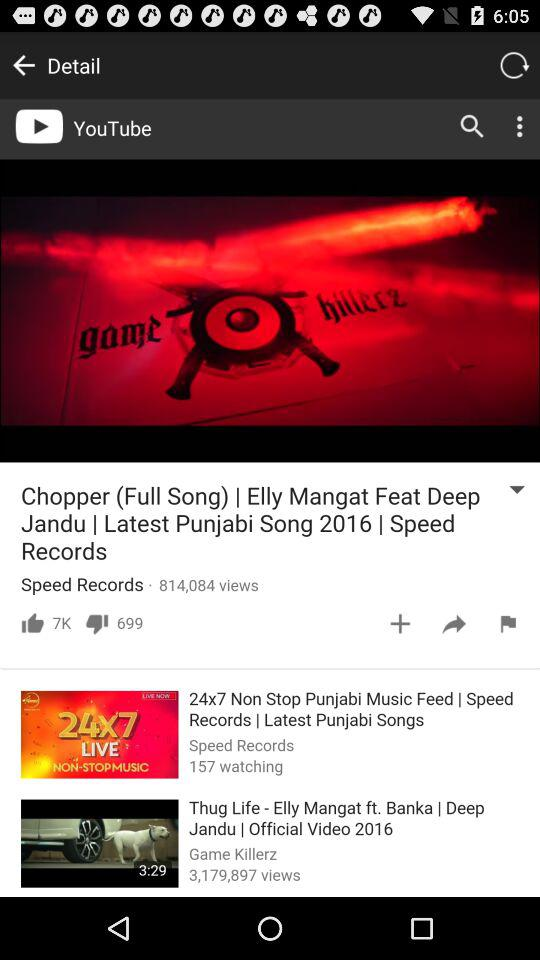How many people are watching "24*7 Non Stop Punjabi Music"? The number of people who are watching "24*7 Non Stop Punjabi Music" is 157. 